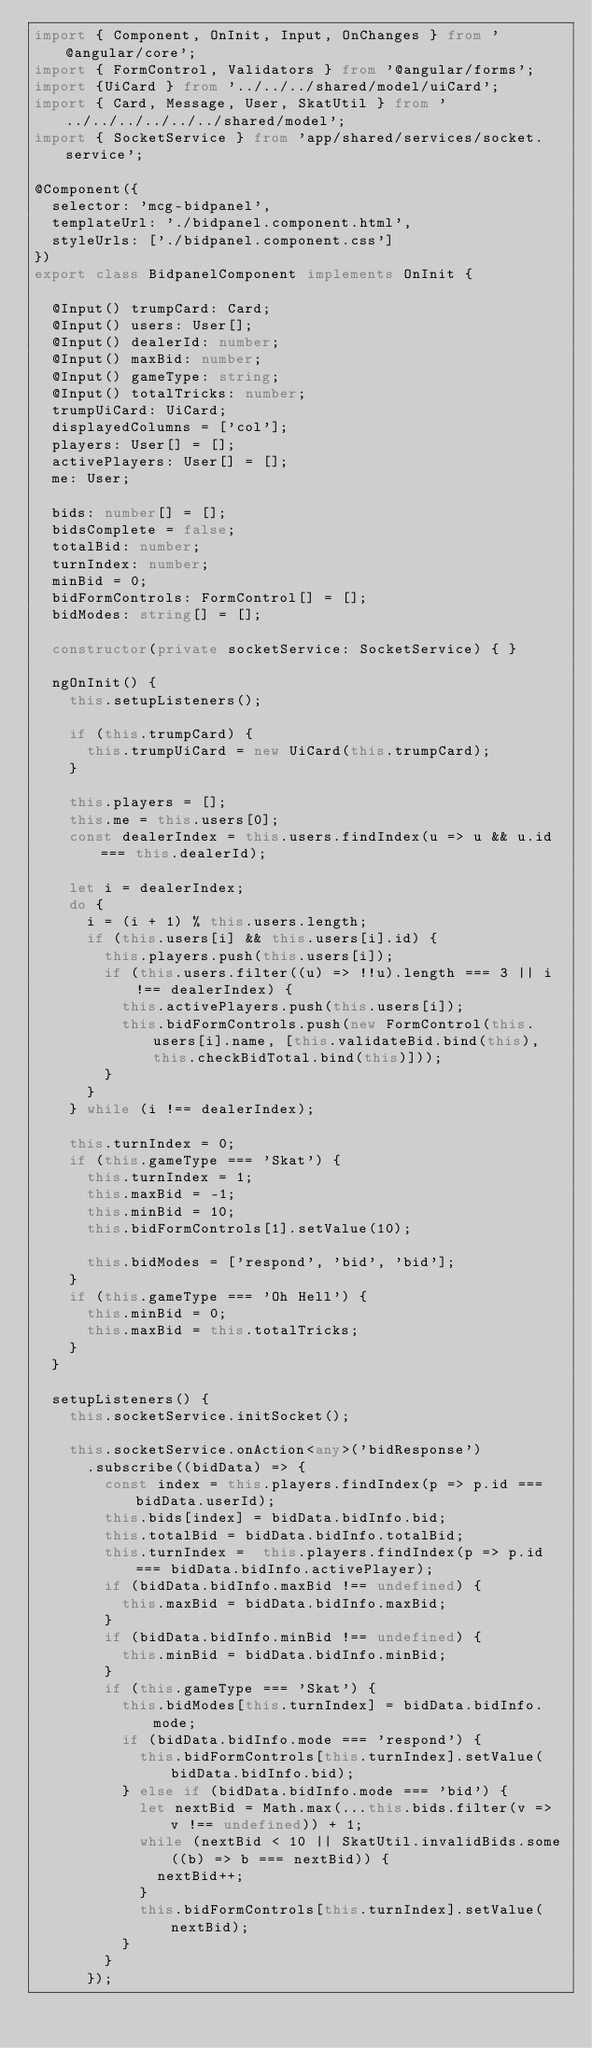Convert code to text. <code><loc_0><loc_0><loc_500><loc_500><_TypeScript_>import { Component, OnInit, Input, OnChanges } from '@angular/core';
import { FormControl, Validators } from '@angular/forms';
import {UiCard } from '../../../shared/model/uiCard';
import { Card, Message, User, SkatUtil } from '../../../../../../shared/model';
import { SocketService } from 'app/shared/services/socket.service';

@Component({
  selector: 'mcg-bidpanel',
  templateUrl: './bidpanel.component.html',
  styleUrls: ['./bidpanel.component.css']
})
export class BidpanelComponent implements OnInit {

  @Input() trumpCard: Card;
  @Input() users: User[];
  @Input() dealerId: number;
  @Input() maxBid: number;
  @Input() gameType: string;
  @Input() totalTricks: number;
  trumpUiCard: UiCard;
  displayedColumns = ['col'];
  players: User[] = [];
  activePlayers: User[] = [];
  me: User;

  bids: number[] = [];
  bidsComplete = false;
  totalBid: number;
  turnIndex: number;
  minBid = 0;
  bidFormControls: FormControl[] = [];
  bidModes: string[] = [];

  constructor(private socketService: SocketService) { }

  ngOnInit() {
    this.setupListeners();

    if (this.trumpCard) {
      this.trumpUiCard = new UiCard(this.trumpCard);
    }

    this.players = [];
    this.me = this.users[0];
    const dealerIndex = this.users.findIndex(u => u && u.id === this.dealerId);

    let i = dealerIndex;
    do {
      i = (i + 1) % this.users.length;
      if (this.users[i] && this.users[i].id) {
        this.players.push(this.users[i]);
        if (this.users.filter((u) => !!u).length === 3 || i !== dealerIndex) {
          this.activePlayers.push(this.users[i]);
          this.bidFormControls.push(new FormControl(this.users[i].name, [this.validateBid.bind(this), this.checkBidTotal.bind(this)]));
        }
      }
    } while (i !== dealerIndex);

    this.turnIndex = 0;
    if (this.gameType === 'Skat') {
      this.turnIndex = 1;
      this.maxBid = -1;
      this.minBid = 10;
      this.bidFormControls[1].setValue(10);

      this.bidModes = ['respond', 'bid', 'bid'];
    }
    if (this.gameType === 'Oh Hell') {
      this.minBid = 0;
      this.maxBid = this.totalTricks;
    }
  }

  setupListeners() {
    this.socketService.initSocket();

    this.socketService.onAction<any>('bidResponse')
      .subscribe((bidData) => {
        const index = this.players.findIndex(p => p.id === bidData.userId);
        this.bids[index] = bidData.bidInfo.bid;
        this.totalBid = bidData.bidInfo.totalBid;
        this.turnIndex =  this.players.findIndex(p => p.id === bidData.bidInfo.activePlayer);
        if (bidData.bidInfo.maxBid !== undefined) {
          this.maxBid = bidData.bidInfo.maxBid;
        }
        if (bidData.bidInfo.minBid !== undefined) {
          this.minBid = bidData.bidInfo.minBid;
        }
        if (this.gameType === 'Skat') {
          this.bidModes[this.turnIndex] = bidData.bidInfo.mode;
          if (bidData.bidInfo.mode === 'respond') {
            this.bidFormControls[this.turnIndex].setValue(bidData.bidInfo.bid);
          } else if (bidData.bidInfo.mode === 'bid') {
            let nextBid = Math.max(...this.bids.filter(v => v !== undefined)) + 1;
            while (nextBid < 10 || SkatUtil.invalidBids.some((b) => b === nextBid)) {
              nextBid++;
            }
            this.bidFormControls[this.turnIndex].setValue(nextBid);
          }
        }
      });
</code> 